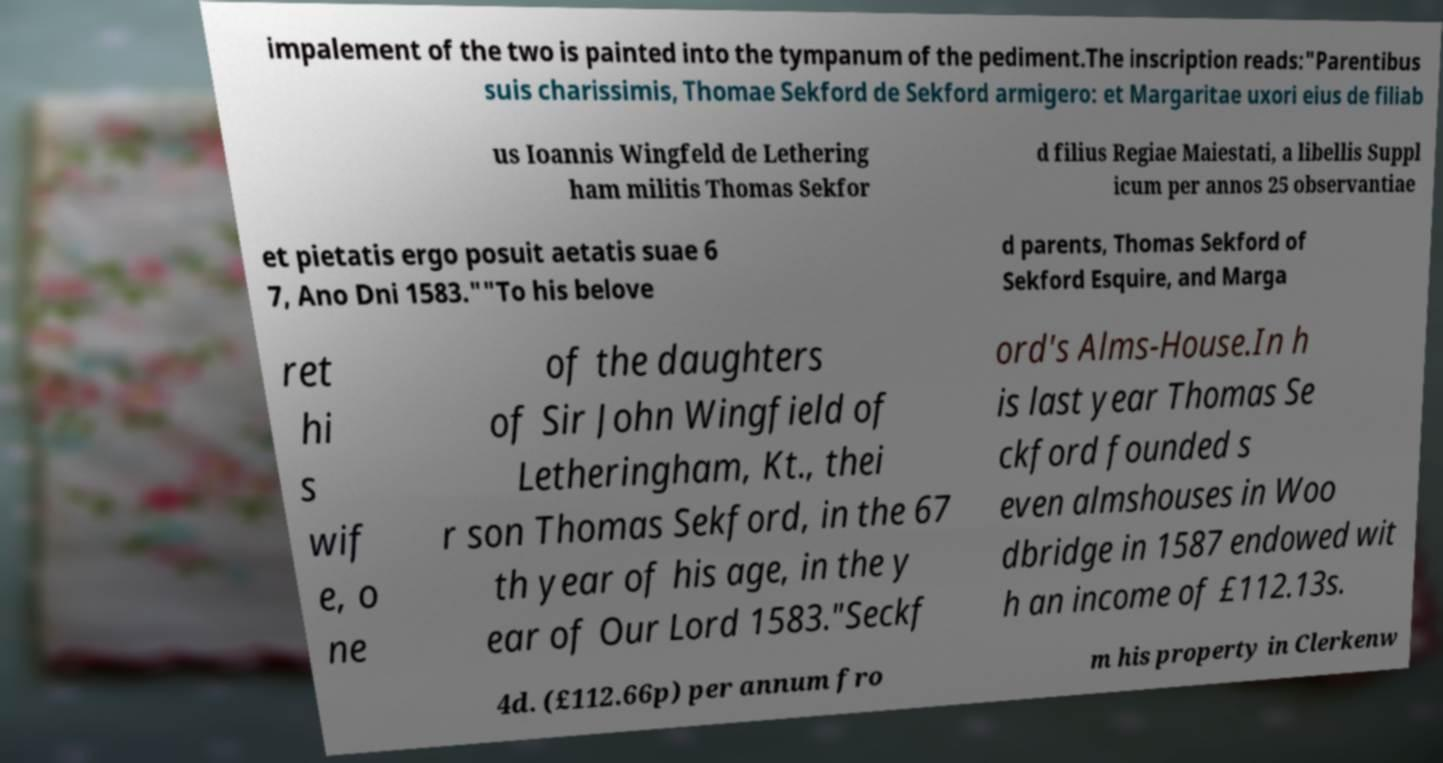For documentation purposes, I need the text within this image transcribed. Could you provide that? impalement of the two is painted into the tympanum of the pediment.The inscription reads:"Parentibus suis charissimis, Thomae Sekford de Sekford armigero: et Margaritae uxori eius de filiab us Ioannis Wingfeld de Lethering ham militis Thomas Sekfor d filius Regiae Maiestati, a libellis Suppl icum per annos 25 observantiae et pietatis ergo posuit aetatis suae 6 7, Ano Dni 1583.""To his belove d parents, Thomas Sekford of Sekford Esquire, and Marga ret hi s wif e, o ne of the daughters of Sir John Wingfield of Letheringham, Kt., thei r son Thomas Sekford, in the 67 th year of his age, in the y ear of Our Lord 1583."Seckf ord's Alms-House.In h is last year Thomas Se ckford founded s even almshouses in Woo dbridge in 1587 endowed wit h an income of £112.13s. 4d. (£112.66p) per annum fro m his property in Clerkenw 